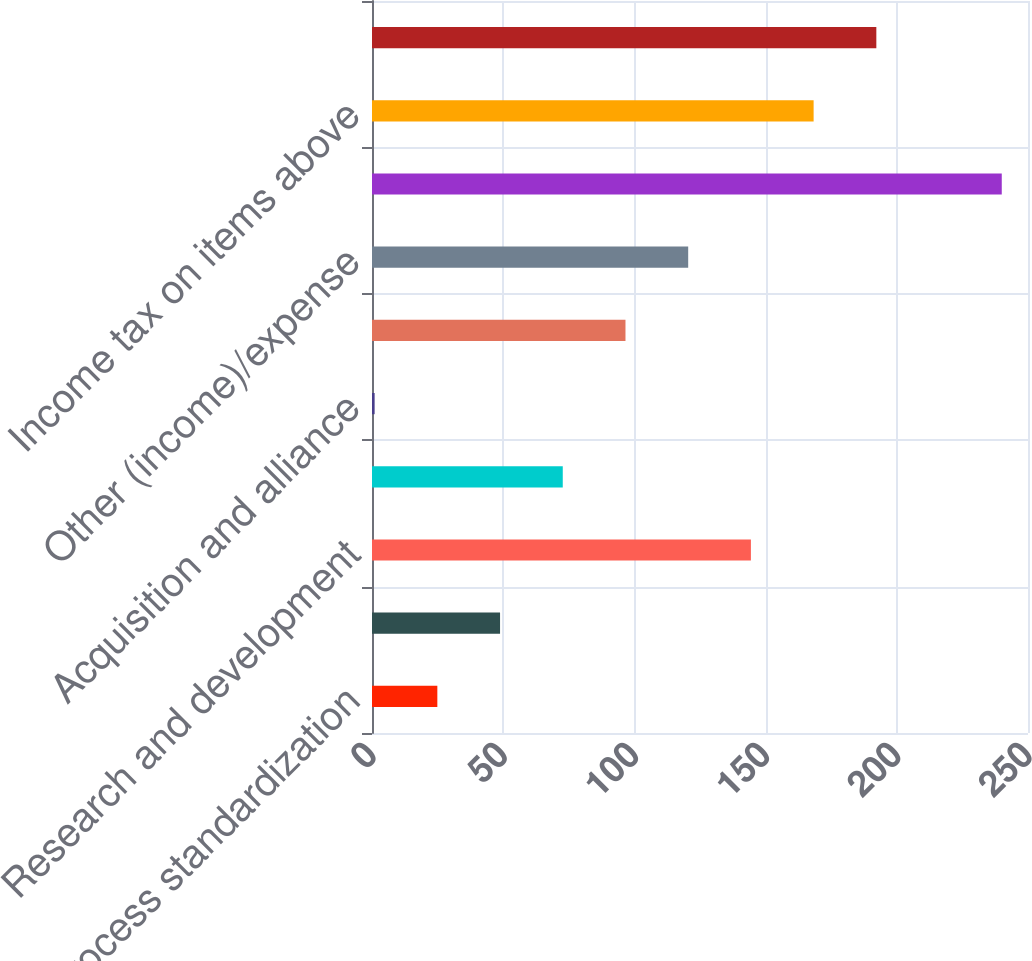Convert chart. <chart><loc_0><loc_0><loc_500><loc_500><bar_chart><fcel>Process standardization<fcel>Marketing selling and<fcel>Research and development<fcel>Provision for restructuring<fcel>Acquisition and alliance<fcel>Litigation<fcel>Other (income)/expense<fcel>Increase to pretax income<fcel>Income tax on items above<fcel>Income taxes<nl><fcel>24.9<fcel>48.8<fcel>144.4<fcel>72.7<fcel>1<fcel>96.6<fcel>120.5<fcel>240<fcel>168.3<fcel>192.2<nl></chart> 